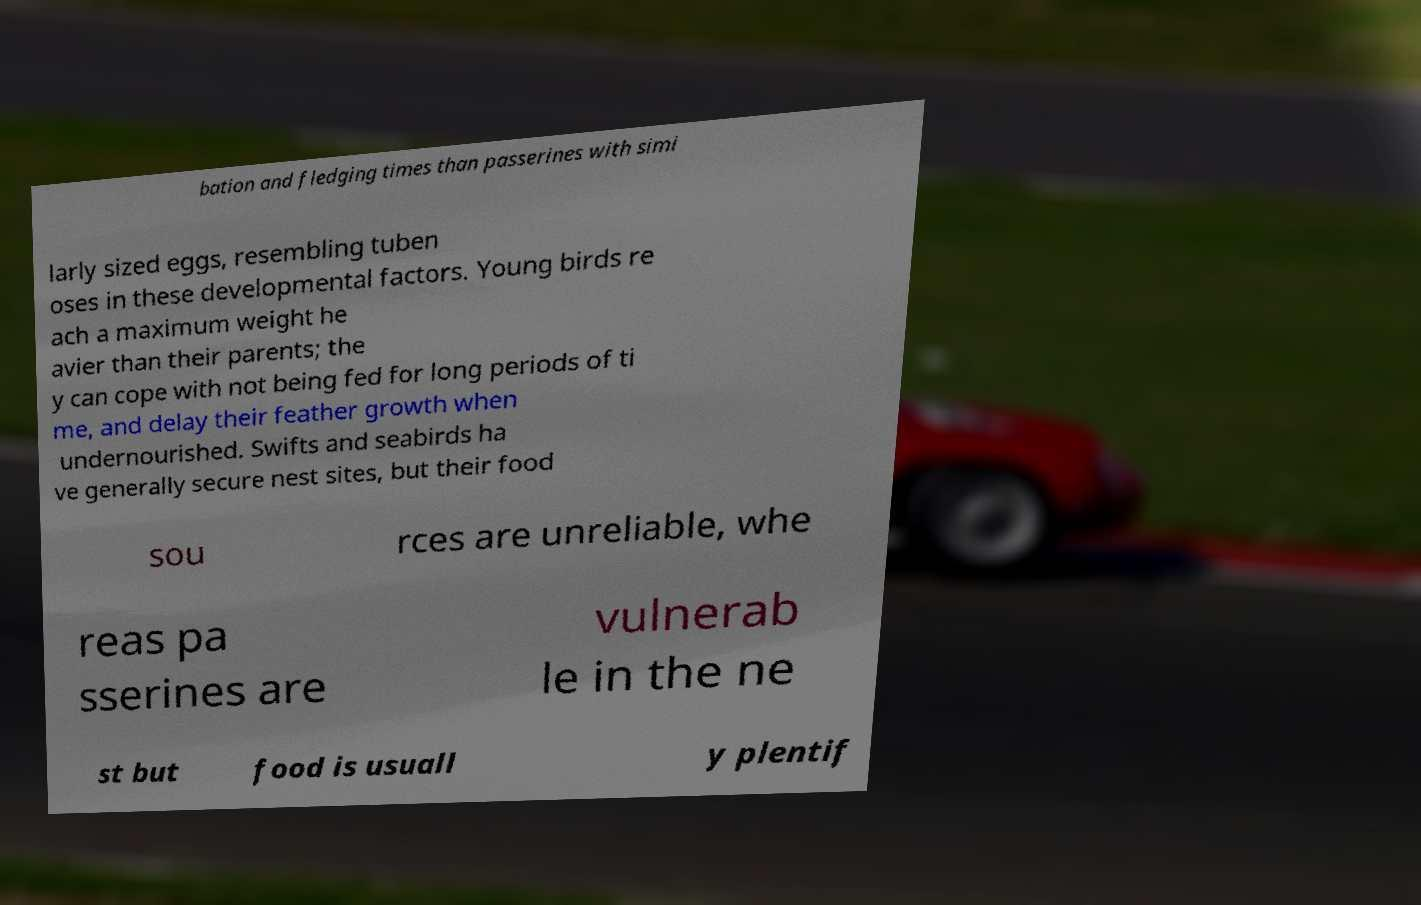Could you extract and type out the text from this image? bation and fledging times than passerines with simi larly sized eggs, resembling tuben oses in these developmental factors. Young birds re ach a maximum weight he avier than their parents; the y can cope with not being fed for long periods of ti me, and delay their feather growth when undernourished. Swifts and seabirds ha ve generally secure nest sites, but their food sou rces are unreliable, whe reas pa sserines are vulnerab le in the ne st but food is usuall y plentif 